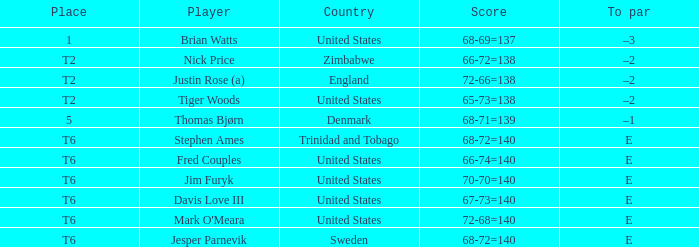From which country did the player with a score of 66-72=138 originate? Zimbabwe. 